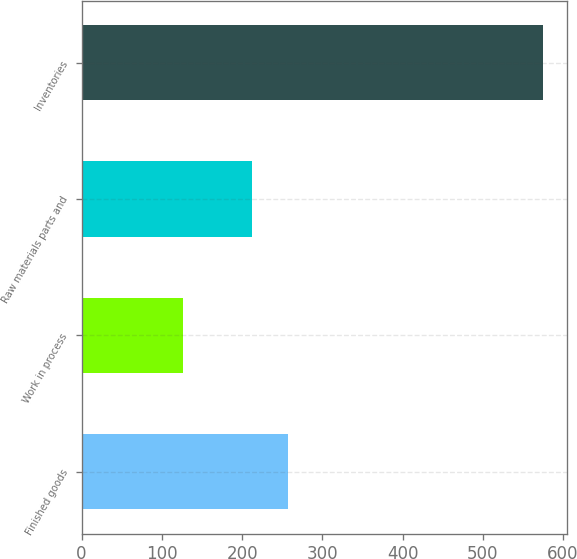Convert chart. <chart><loc_0><loc_0><loc_500><loc_500><bar_chart><fcel>Finished goods<fcel>Work in process<fcel>Raw materials parts and<fcel>Inventories<nl><fcel>257.56<fcel>125.9<fcel>212.6<fcel>575.5<nl></chart> 